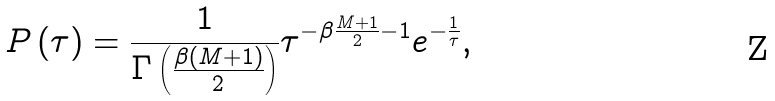Convert formula to latex. <formula><loc_0><loc_0><loc_500><loc_500>P \left ( \tau \right ) = \frac { 1 } { \Gamma \left ( \frac { \beta ( M + 1 ) } { 2 } \right ) } \tau ^ { - \beta \frac { M + 1 } { 2 } - 1 } e ^ { - \frac { 1 } { \tau } } ,</formula> 